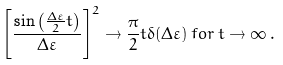Convert formula to latex. <formula><loc_0><loc_0><loc_500><loc_500>\left [ \frac { \sin \left ( \frac { \Delta \varepsilon } { 2 } t \right ) } { \Delta \varepsilon } \right ] ^ { 2 } \rightarrow \frac { \pi } { 2 } t \delta ( \Delta \varepsilon ) \, f o r \, t \rightarrow \infty \, .</formula> 